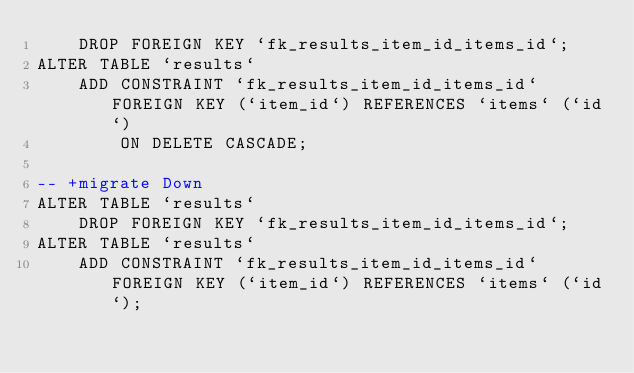Convert code to text. <code><loc_0><loc_0><loc_500><loc_500><_SQL_>    DROP FOREIGN KEY `fk_results_item_id_items_id`;
ALTER TABLE `results`
    ADD CONSTRAINT `fk_results_item_id_items_id` FOREIGN KEY (`item_id`) REFERENCES `items` (`id`)
        ON DELETE CASCADE;

-- +migrate Down
ALTER TABLE `results`
    DROP FOREIGN KEY `fk_results_item_id_items_id`;
ALTER TABLE `results`
    ADD CONSTRAINT `fk_results_item_id_items_id` FOREIGN KEY (`item_id`) REFERENCES `items` (`id`);
</code> 